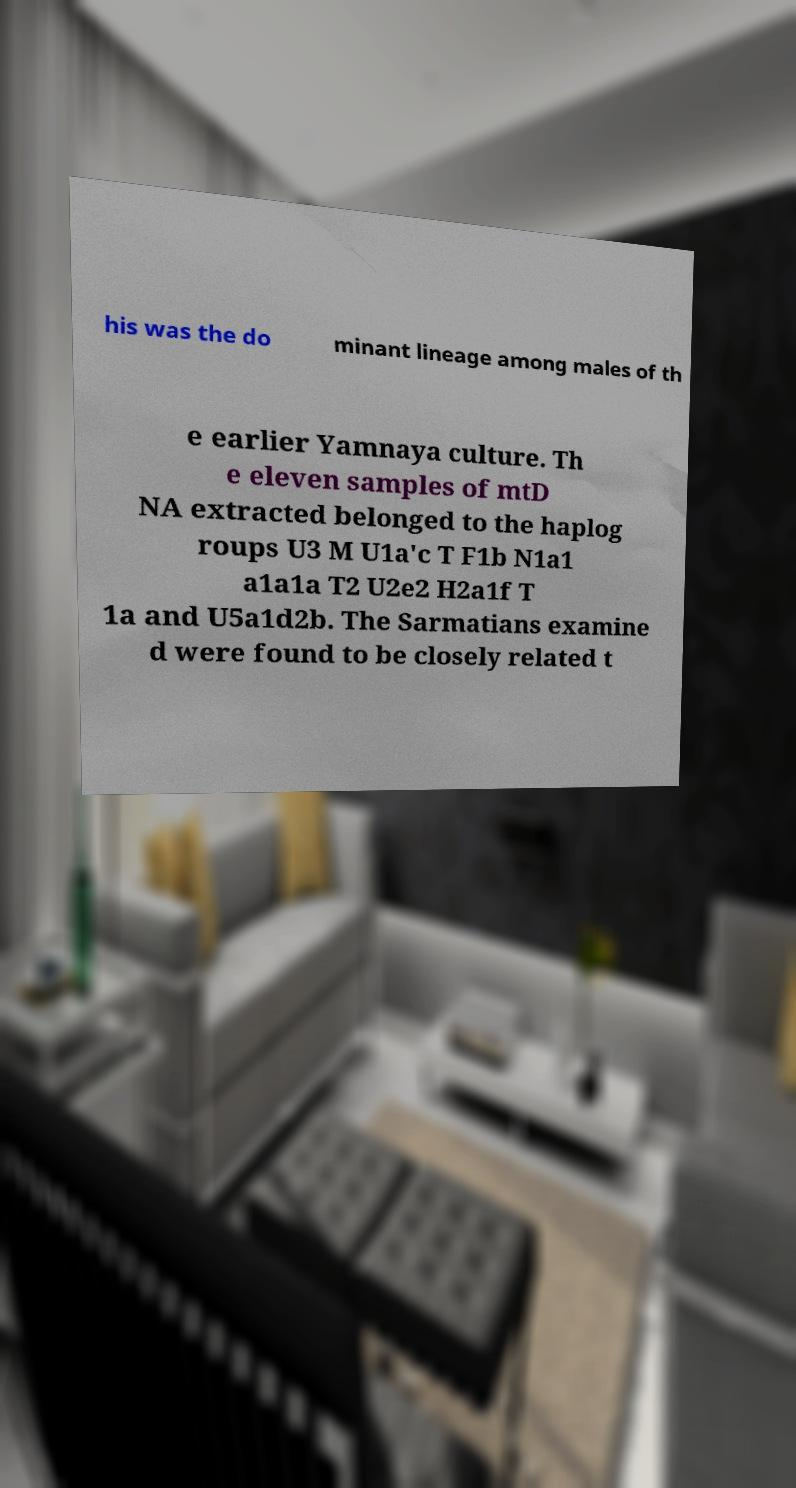There's text embedded in this image that I need extracted. Can you transcribe it verbatim? his was the do minant lineage among males of th e earlier Yamnaya culture. Th e eleven samples of mtD NA extracted belonged to the haplog roups U3 M U1a'c T F1b N1a1 a1a1a T2 U2e2 H2a1f T 1a and U5a1d2b. The Sarmatians examine d were found to be closely related t 